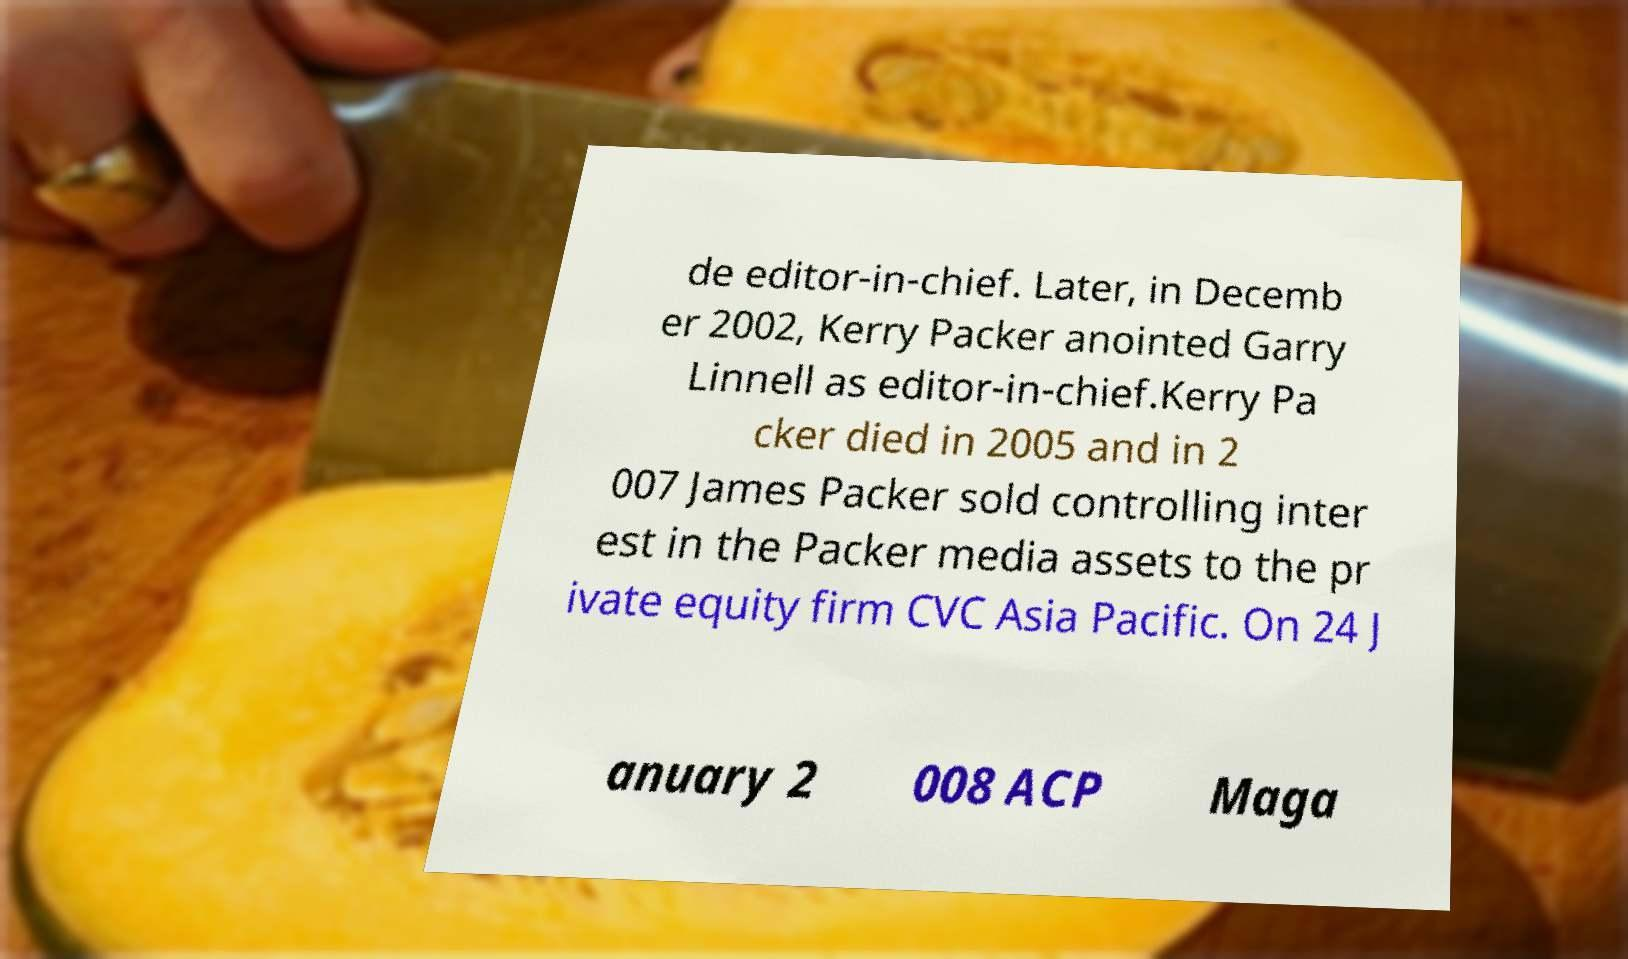There's text embedded in this image that I need extracted. Can you transcribe it verbatim? de editor-in-chief. Later, in Decemb er 2002, Kerry Packer anointed Garry Linnell as editor-in-chief.Kerry Pa cker died in 2005 and in 2 007 James Packer sold controlling inter est in the Packer media assets to the pr ivate equity firm CVC Asia Pacific. On 24 J anuary 2 008 ACP Maga 